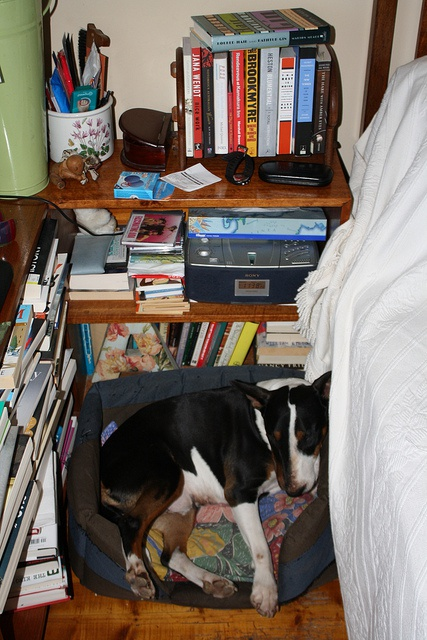Describe the objects in this image and their specific colors. I can see bed in olive, lightgray, darkgray, and black tones, dog in olive, black, darkgray, maroon, and gray tones, book in olive, black, darkgray, gray, and lightgray tones, book in olive, gray, black, and darkgray tones, and book in olive, gray, lightgray, darkgray, and black tones in this image. 